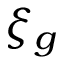Convert formula to latex. <formula><loc_0><loc_0><loc_500><loc_500>\xi _ { g }</formula> 